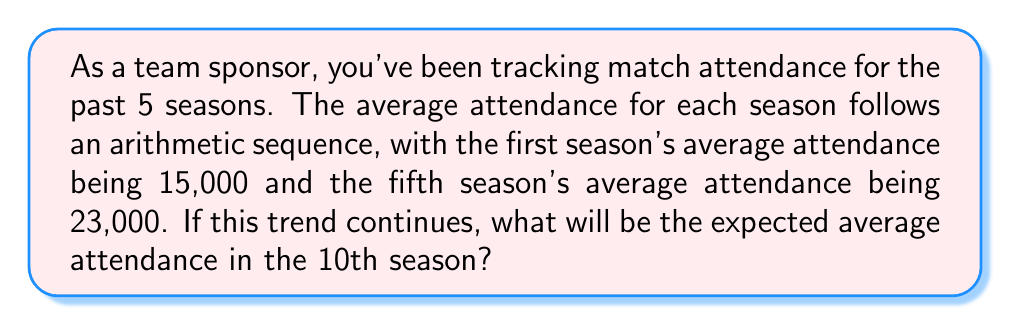Provide a solution to this math problem. Let's approach this step-by-step using arithmetic sequence principles:

1) In an arithmetic sequence, the difference between any two consecutive terms is constant. Let's call this common difference $d$.

2) We're given the first term $a_1 = 15,000$ and the fifth term $a_5 = 23,000$.

3) The formula for the nth term of an arithmetic sequence is:

   $$a_n = a_1 + (n-1)d$$

4) We can use this to set up an equation for the 5th term:

   $$23,000 = 15,000 + (5-1)d$$

5) Simplify:

   $$23,000 = 15,000 + 4d$$
   $$8,000 = 4d$$
   $$d = 2,000$$

6) So, the attendance increases by 2,000 each season.

7) Now, we need to find the 10th term. We can use the same formula:

   $$a_{10} = a_1 + (10-1)d$$
   $$a_{10} = 15,000 + (9)(2,000)$$
   $$a_{10} = 15,000 + 18,000$$
   $$a_{10} = 33,000$$

Therefore, if the trend continues, the expected average attendance in the 10th season will be 33,000.
Answer: 33,000 